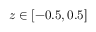<formula> <loc_0><loc_0><loc_500><loc_500>z \in [ - 0 . 5 , 0 . 5 ]</formula> 